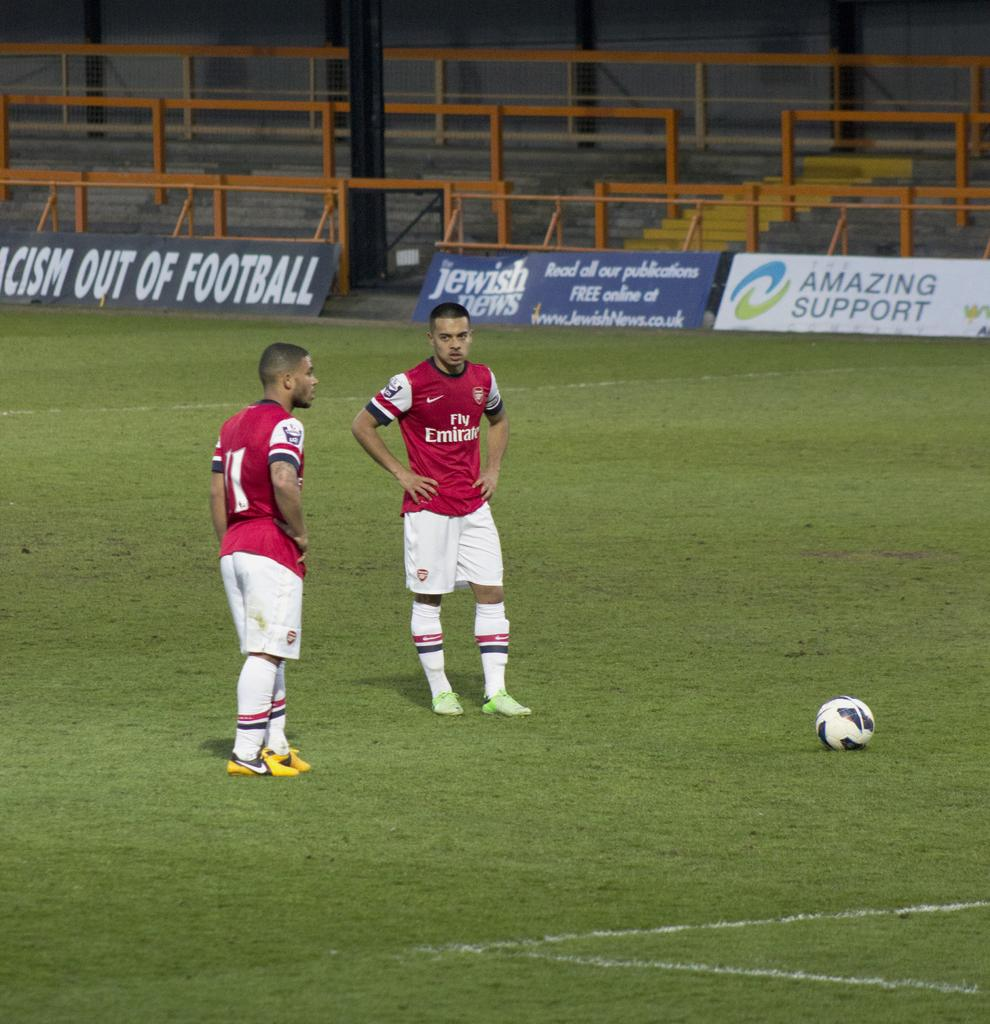<image>
Render a clear and concise summary of the photo. Two Fly Emirate soccer players stand on a field wearing red jerseys. 